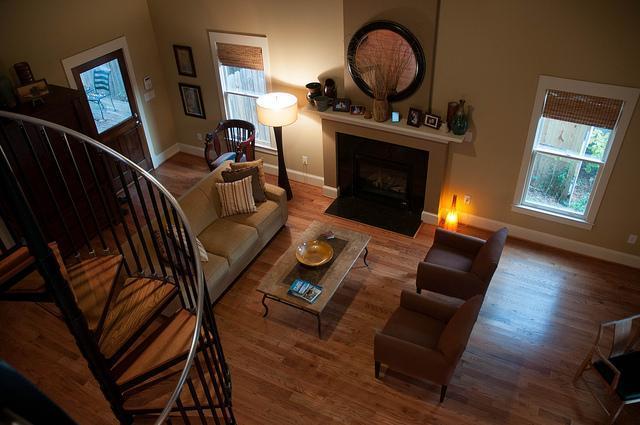How many pillows are on the furniture, excluding the ones that are part of the furniture?
Give a very brief answer. 4. How many chairs are in the picture?
Give a very brief answer. 3. How many people are in the picture?
Give a very brief answer. 0. 